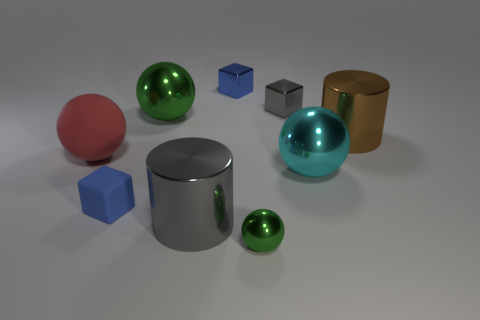There is a green shiny sphere on the left side of the metallic cylinder that is in front of the small rubber cube; how big is it?
Make the answer very short. Large. There is a cylinder that is behind the large cylinder left of the blue thing that is on the right side of the rubber cube; what size is it?
Offer a very short reply. Large. There is a matte thing that is to the right of the red rubber sphere; is it the same shape as the blue thing behind the large cyan shiny thing?
Make the answer very short. Yes. What number of other things are there of the same color as the tiny matte cube?
Your answer should be compact. 1. Is the size of the cylinder left of the brown shiny object the same as the small gray block?
Make the answer very short. No. Do the big gray object that is on the left side of the big cyan metal thing and the blue thing behind the large green metal ball have the same material?
Your answer should be very brief. Yes. Are there any blue blocks that have the same size as the gray cube?
Make the answer very short. Yes. There is a gray object that is behind the cylinder that is in front of the large object that is on the right side of the cyan sphere; what shape is it?
Offer a terse response. Cube. Are there more objects behind the big green metal sphere than rubber spheres?
Offer a terse response. Yes. Is there a red rubber thing of the same shape as the tiny green metal object?
Provide a short and direct response. Yes. 